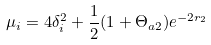<formula> <loc_0><loc_0><loc_500><loc_500>\mu _ { i } = 4 \delta _ { i } ^ { 2 } + \frac { 1 } { 2 } ( 1 + \Theta _ { a 2 } ) e ^ { - 2 r _ { 2 } }</formula> 